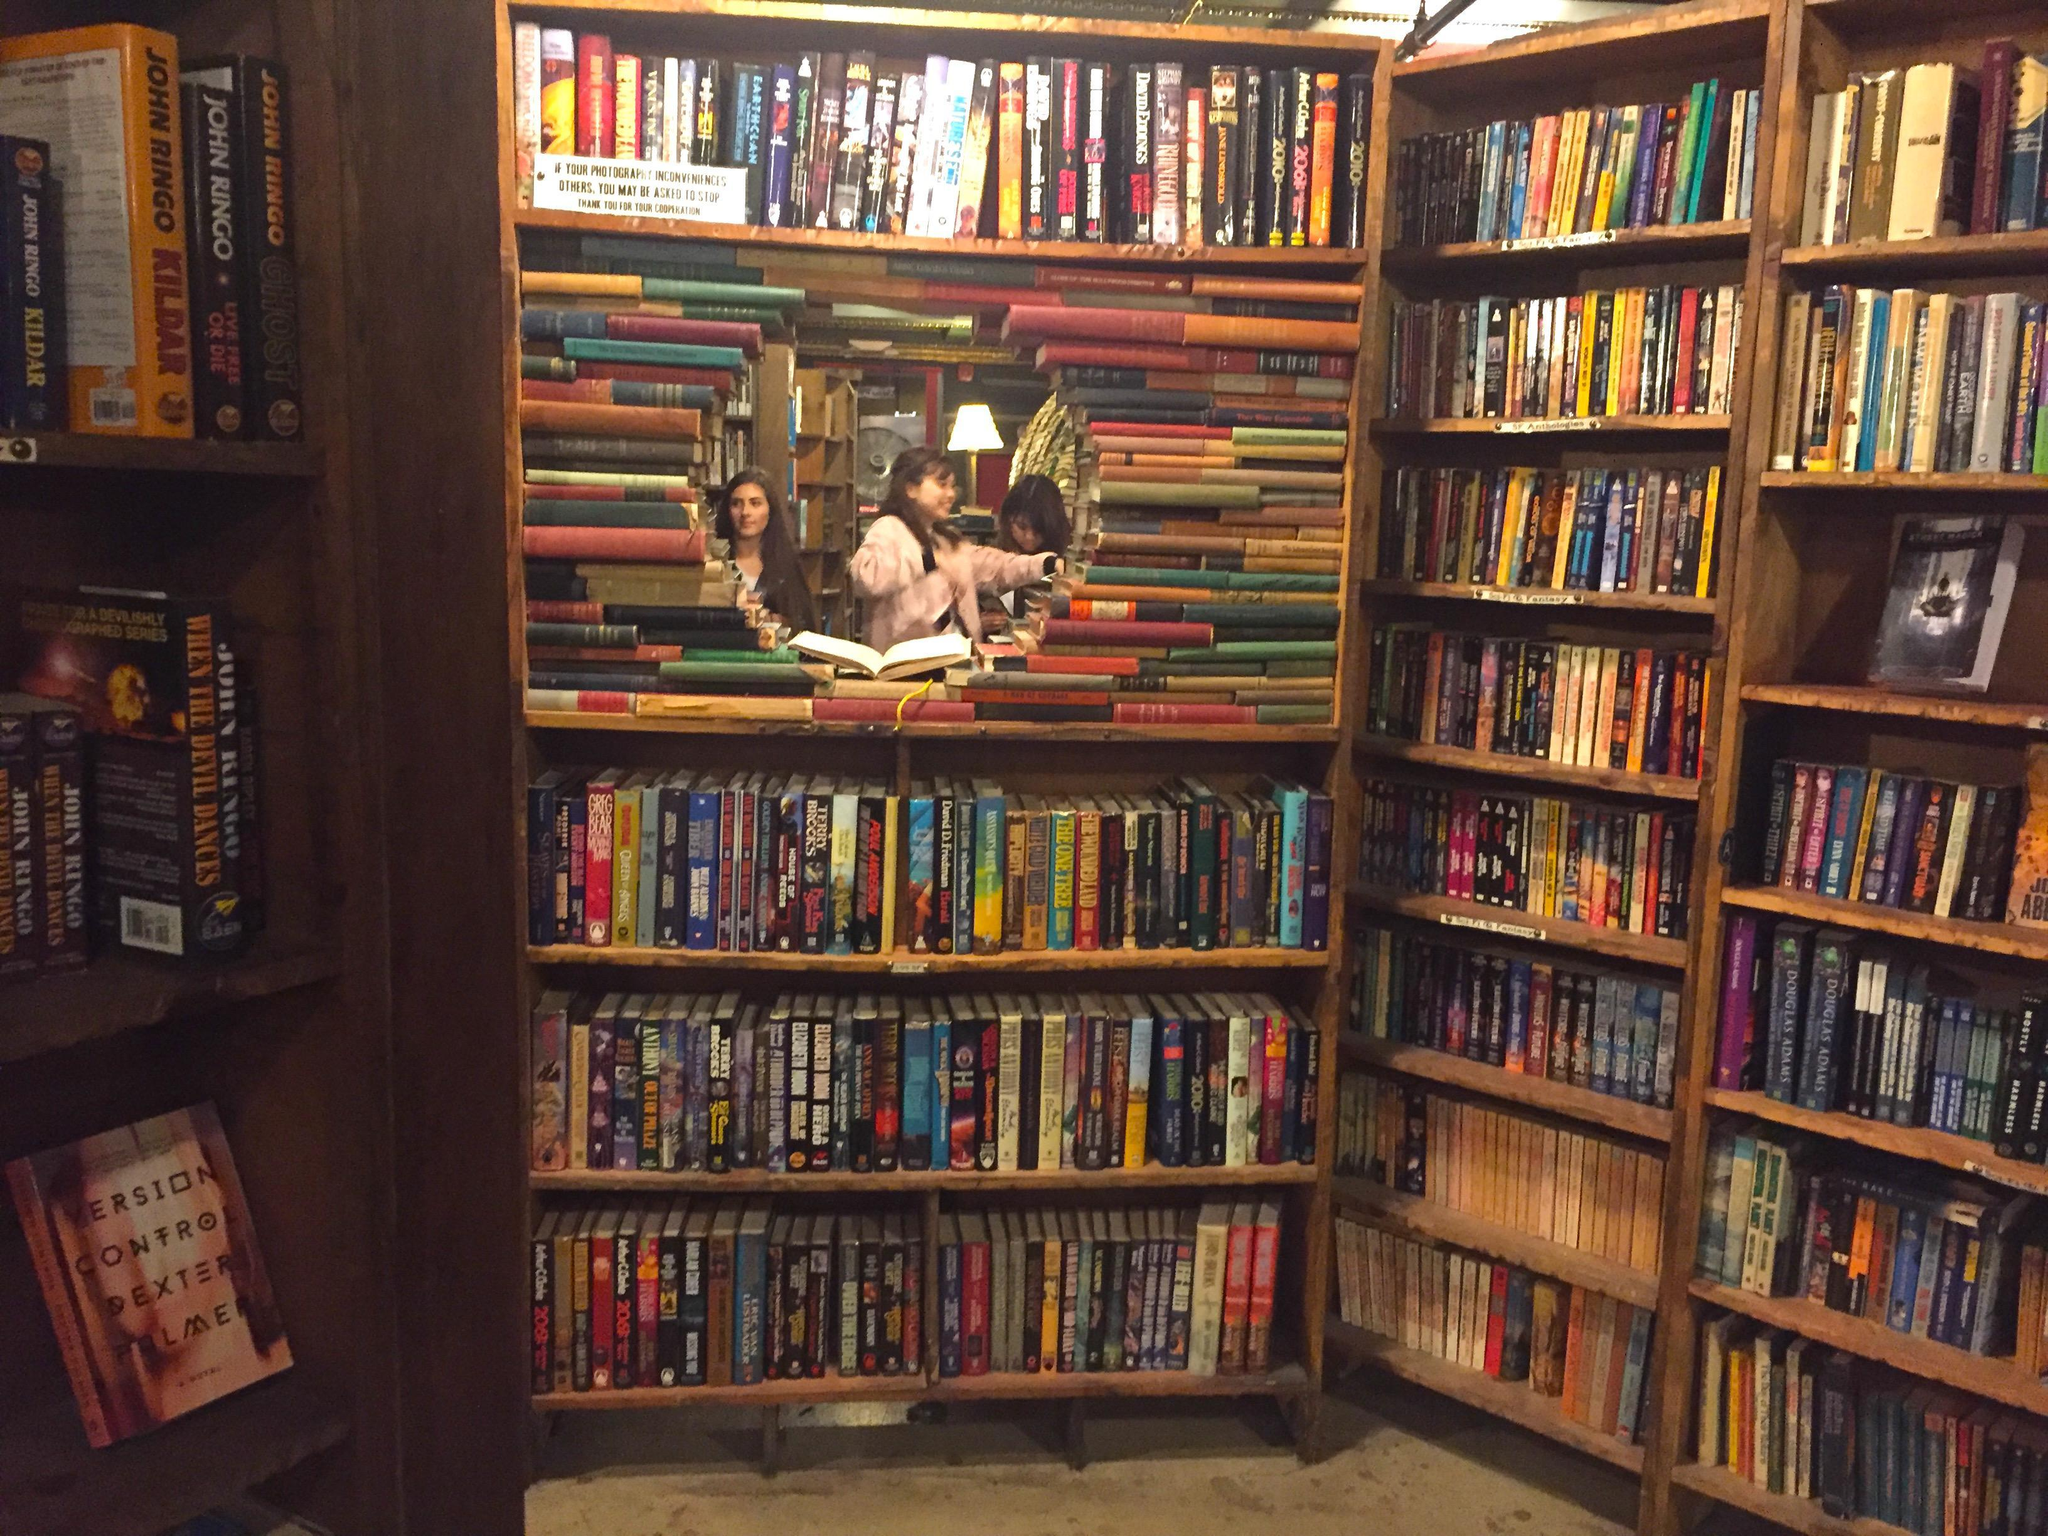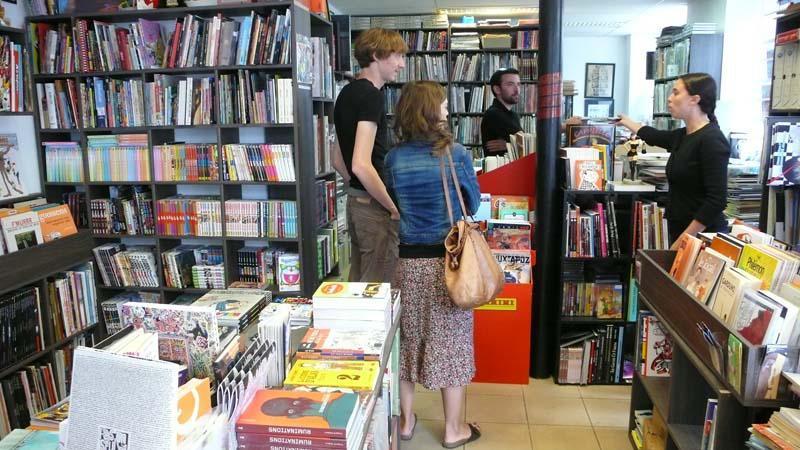The first image is the image on the left, the second image is the image on the right. Analyze the images presented: Is the assertion "In the right image, a woman with a large handbag is framed by an opening between bookshelves." valid? Answer yes or no. Yes. The first image is the image on the left, the second image is the image on the right. For the images displayed, is the sentence "At least two people are shopping for books." factually correct? Answer yes or no. Yes. 